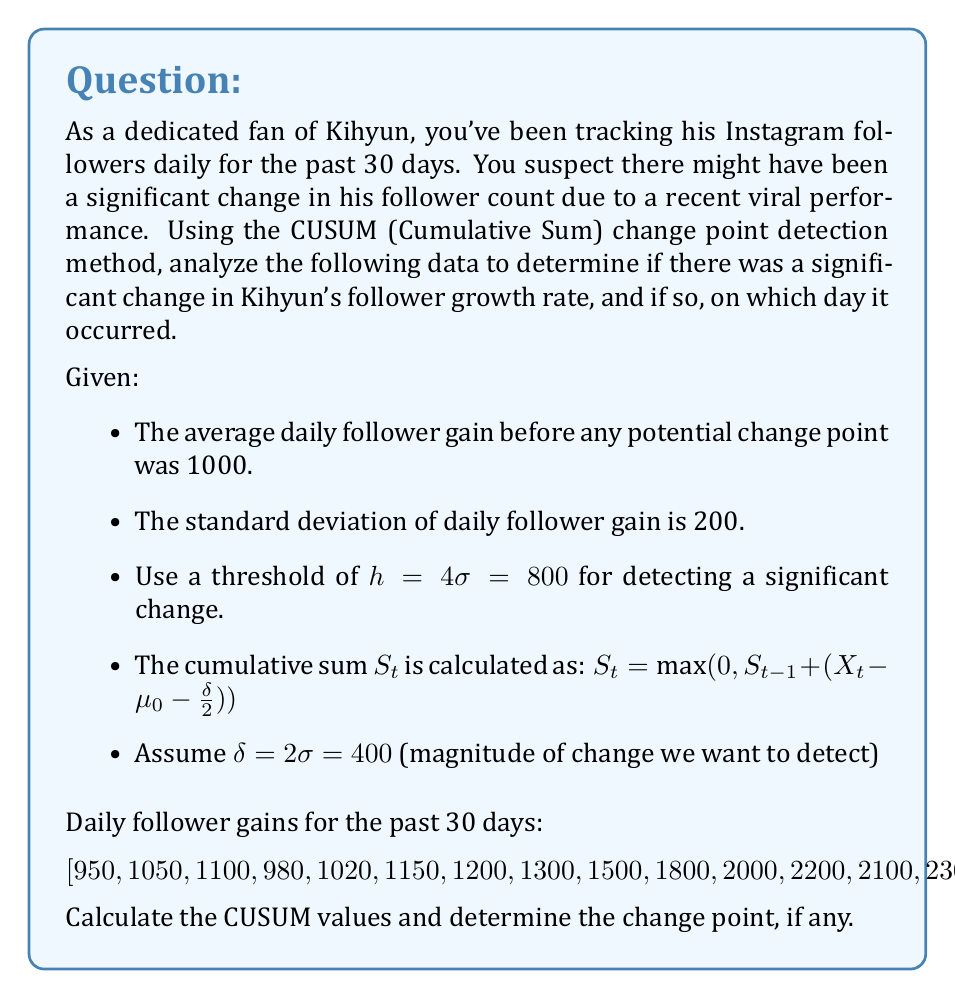Help me with this question. To solve this problem, we'll follow these steps:

1) Calculate the CUSUM values for each day.
2) Identify if and when the CUSUM exceeds the threshold.

Step 1: Calculate CUSUM values

We'll use the formula: $S_t = \max(0, S_{t-1} + (X_t - \mu_0 - \frac{\delta}{2}))$

Where:
$\mu_0 = 1000$ (average daily follower gain before change)
$\delta = 400$ (magnitude of change we want to detect)

Let's calculate the first few values:

Day 1: $S_1 = \max(0, 0 + (950 - 1000 - \frac{400}{2})) = \max(0, -250) = 0$
Day 2: $S_2 = \max(0, 0 + (1050 - 1000 - 200)) = 0$
Day 3: $S_3 = \max(0, 0 + (1100 - 1000 - 200)) = 0$
...

Continuing this process, we get the following CUSUM values:

$[0, 0, 0, 0, 0, 0, 0, 100, 400, 1000, 1800, 2800, 3700, 4800, 5850, 6800, 7650, 8550, 9350, 10050, 10800, 11650, 12550, 13500, 14500, 15550, 16650, 17800, 19000, 20250]$

Step 2: Identify the change point

The threshold is $h = 800$. We see that the CUSUM value exceeds this threshold on day 9, where $S_9 = 1000 > 800$.

Therefore, the change point is detected on day 9.

This aligns with the data, as we can see the follower gains start to increase significantly from day 9 onwards, likely due to Kihyun's viral performance.
Answer: The change point in Kihyun's Instagram follower growth rate is detected on day 9. 